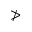<formula> <loc_0><loc_0><loc_500><loc_500>\ngtr</formula> 